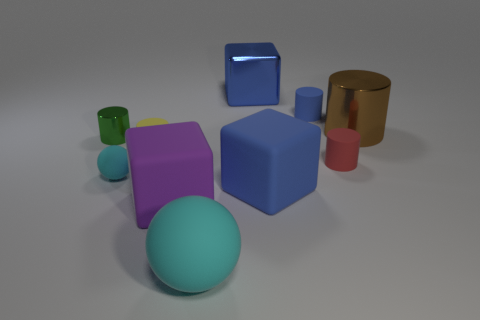What number of cyan rubber things are the same size as the purple rubber block?
Offer a very short reply. 1. What number of blue blocks are in front of the matte block that is on the left side of the big metallic thing to the left of the large metallic cylinder?
Offer a very short reply. 0. What number of blue things are left of the tiny blue matte object and behind the big brown cylinder?
Keep it short and to the point. 1. Are there any other things that are the same color as the tiny rubber sphere?
Offer a terse response. Yes. How many metallic objects are purple cylinders or small blue cylinders?
Make the answer very short. 0. There is a large blue object on the right side of the large object that is behind the small rubber object that is behind the yellow object; what is its material?
Provide a short and direct response. Rubber. The large blue thing in front of the small shiny cylinder that is in front of the blue metallic object is made of what material?
Give a very brief answer. Rubber. There is a cube that is behind the brown thing; is it the same size as the cyan object that is to the left of the large cyan matte ball?
Offer a terse response. No. Is there any other thing that is made of the same material as the purple cube?
Provide a short and direct response. Yes. How many large objects are cyan things or brown shiny things?
Offer a terse response. 2. 